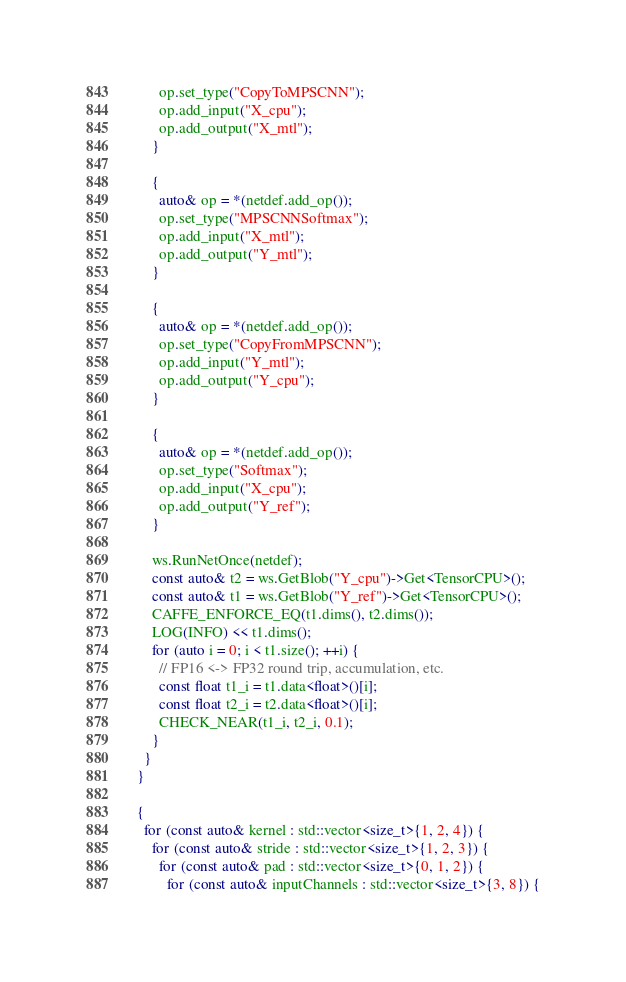<code> <loc_0><loc_0><loc_500><loc_500><_ObjectiveC_>        op.set_type("CopyToMPSCNN");
        op.add_input("X_cpu");
        op.add_output("X_mtl");
      }

      {
        auto& op = *(netdef.add_op());
        op.set_type("MPSCNNSoftmax");
        op.add_input("X_mtl");
        op.add_output("Y_mtl");
      }

      {
        auto& op = *(netdef.add_op());
        op.set_type("CopyFromMPSCNN");
        op.add_input("Y_mtl");
        op.add_output("Y_cpu");
      }

      {
        auto& op = *(netdef.add_op());
        op.set_type("Softmax");
        op.add_input("X_cpu");
        op.add_output("Y_ref");
      }

      ws.RunNetOnce(netdef);
      const auto& t2 = ws.GetBlob("Y_cpu")->Get<TensorCPU>();
      const auto& t1 = ws.GetBlob("Y_ref")->Get<TensorCPU>();
      CAFFE_ENFORCE_EQ(t1.dims(), t2.dims());
      LOG(INFO) << t1.dims();
      for (auto i = 0; i < t1.size(); ++i) {
        // FP16 <-> FP32 round trip, accumulation, etc.
        const float t1_i = t1.data<float>()[i];
        const float t2_i = t2.data<float>()[i];
        CHECK_NEAR(t1_i, t2_i, 0.1);
      }
    }
  }

  {
    for (const auto& kernel : std::vector<size_t>{1, 2, 4}) {
      for (const auto& stride : std::vector<size_t>{1, 2, 3}) {
        for (const auto& pad : std::vector<size_t>{0, 1, 2}) {
          for (const auto& inputChannels : std::vector<size_t>{3, 8}) {</code> 